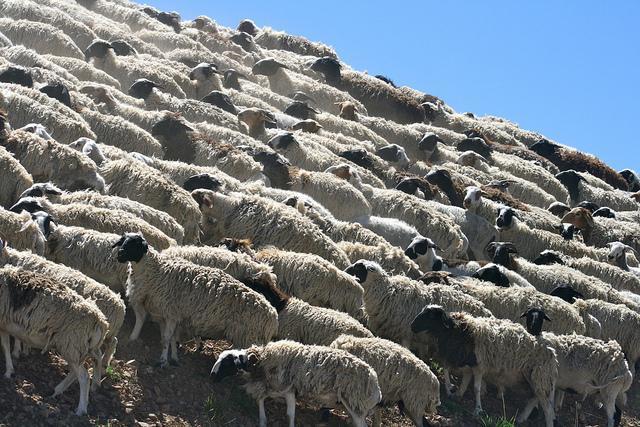How many sheep are in the photo?
Give a very brief answer. 14. 